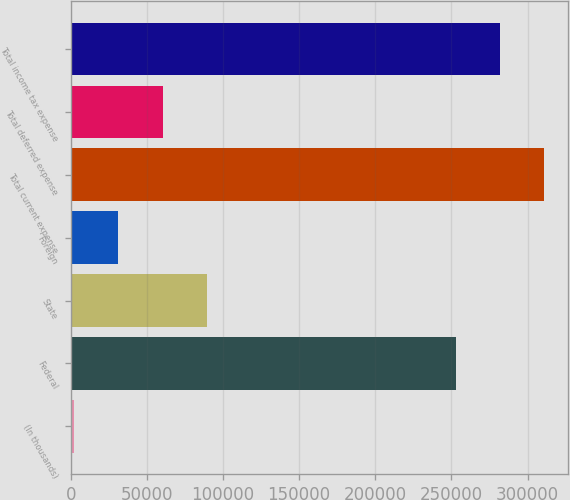<chart> <loc_0><loc_0><loc_500><loc_500><bar_chart><fcel>(In thousands)<fcel>Federal<fcel>State<fcel>Foreign<fcel>Total current expense<fcel>Total deferred expense<fcel>Total income tax expense<nl><fcel>2016<fcel>252795<fcel>89451.3<fcel>31161.1<fcel>311095<fcel>60306.2<fcel>281950<nl></chart> 